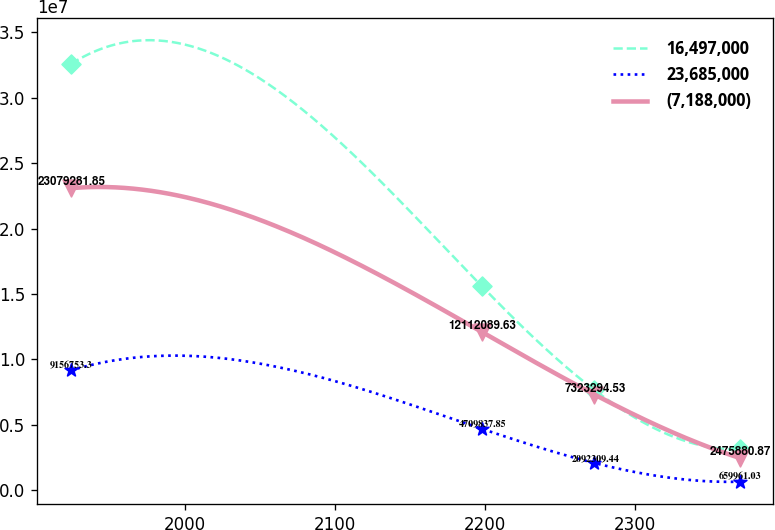<chart> <loc_0><loc_0><loc_500><loc_500><line_chart><ecel><fcel>16,497,000<fcel>23,685,000<fcel>(7,188,000)<nl><fcel>1924.06<fcel>3.25534e+07<fcel>9.15675e+06<fcel>2.30793e+07<nl><fcel>2197.76<fcel>1.56161e+07<fcel>4.70984e+06<fcel>1.21121e+07<nl><fcel>2272.9<fcel>7.66886e+06<fcel>2.09231e+06<fcel>7.32329e+06<nl><fcel>2369.66<fcel>3.14042e+06<fcel>659961<fcel>2.47588e+06<nl></chart> 